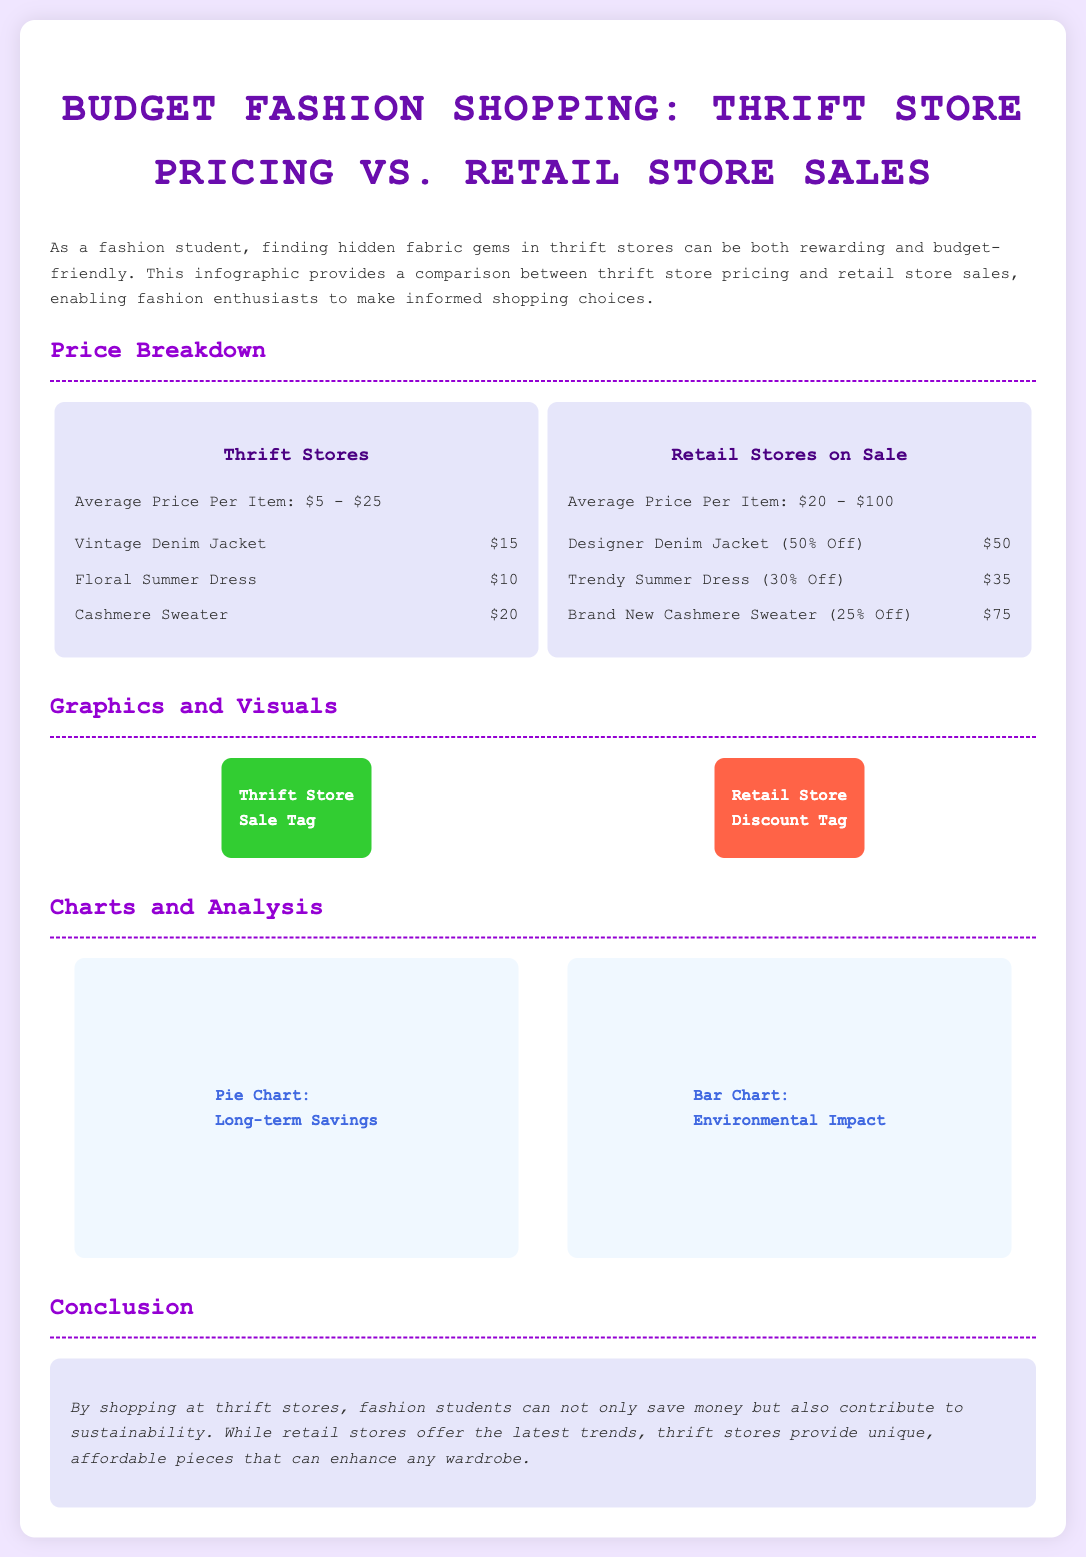what is the average price per item at thrift stores? The average price per item at thrift stores is mentioned in the document as $5 - $25.
Answer: $5 - $25 what is the price of a Vintage Denim Jacket at thrift stores? The price listed for a Vintage Denim Jacket at thrift stores is $15.
Answer: $15 what is the price of a Designer Denim Jacket on sale at retail stores? The document specifies that the price for a Designer Denim Jacket on sale at retail stores is $50.
Answer: $50 which item has the highest price listed in thrift stores? The item with the highest price listed in thrift stores is the Cashmere Sweater, which costs $20.
Answer: Cashmere Sweater how much can be saved in the long term by shopping at thrift stores? The infographic suggests that thrift stores provide long-term savings, but it does not specify an exact amount. It is implied to be significant.
Answer: Not specified which style of dress is offered at a lower price at thrift stores? The Floral Summer Dress at thrift stores is priced at $10, while the similar item at retail costs $35, making thrift stores cheaper.
Answer: Floral Summer Dress what color is the thrift store sale tag? The thrift store sale tag is colored bright green as indicated in the infographic.
Answer: Green what type of chart analyzes environmental impact? The document describes a bar chart as analyzing environmental impact.
Answer: Bar Chart is there a conclusion regarding sustainability in thrift shopping? The conclusion in the document emphasizes that shopping at thrift stores contributes to sustainability.
Answer: Yes 